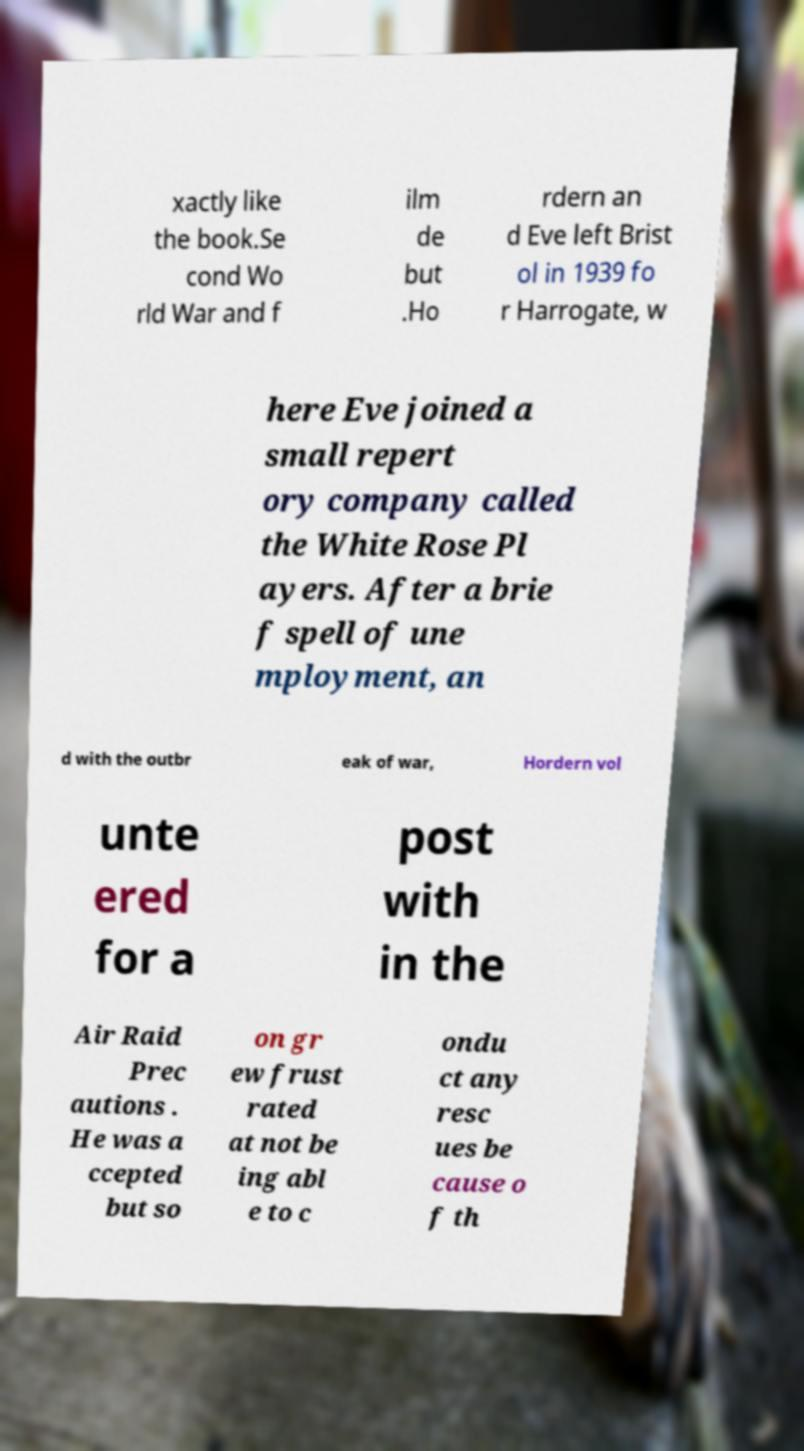Could you assist in decoding the text presented in this image and type it out clearly? xactly like the book.Se cond Wo rld War and f ilm de but .Ho rdern an d Eve left Brist ol in 1939 fo r Harrogate, w here Eve joined a small repert ory company called the White Rose Pl ayers. After a brie f spell of une mployment, an d with the outbr eak of war, Hordern vol unte ered for a post with in the Air Raid Prec autions . He was a ccepted but so on gr ew frust rated at not be ing abl e to c ondu ct any resc ues be cause o f th 